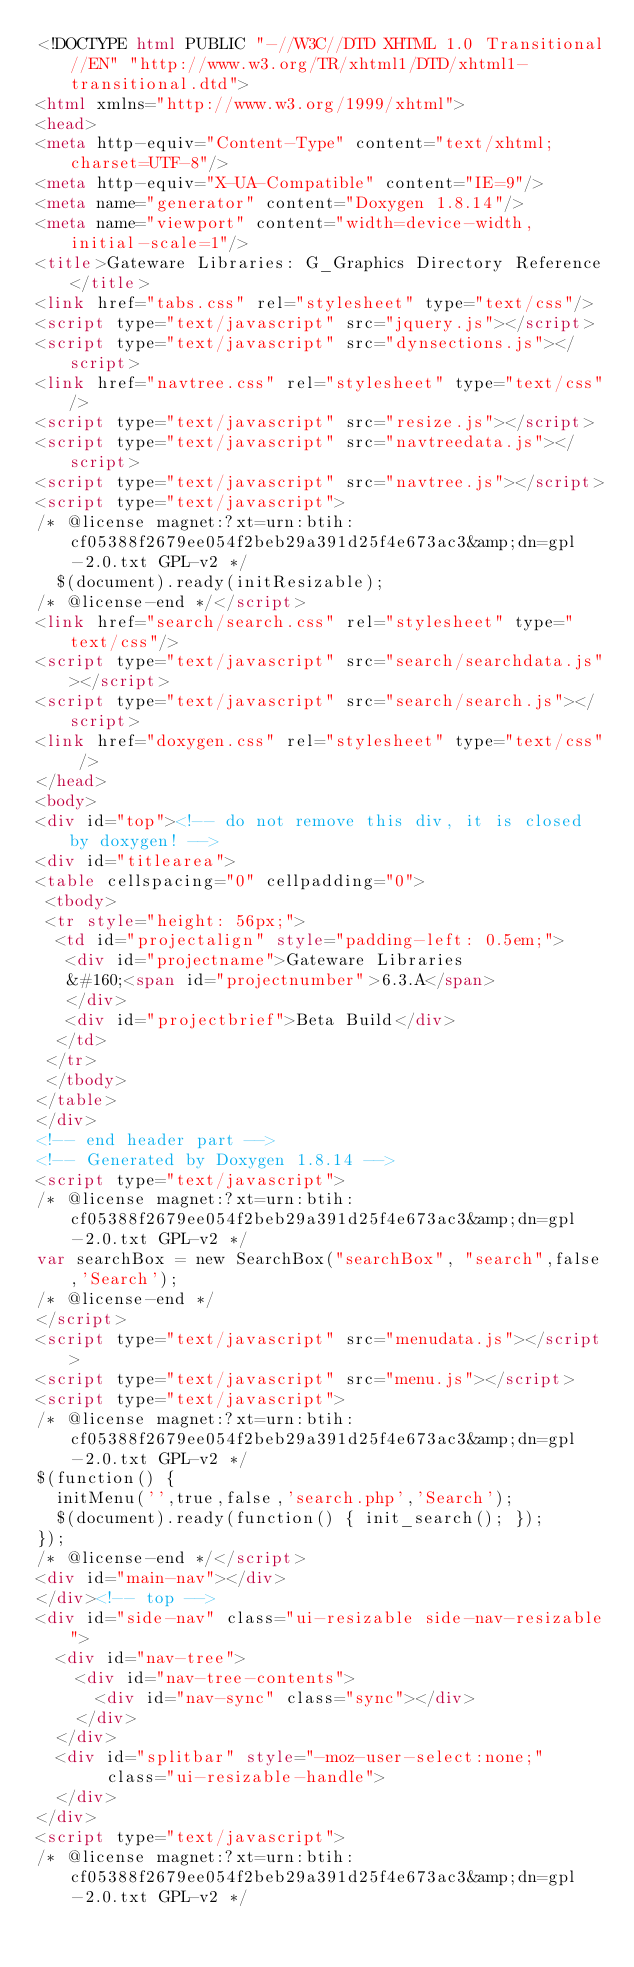Convert code to text. <code><loc_0><loc_0><loc_500><loc_500><_HTML_><!DOCTYPE html PUBLIC "-//W3C//DTD XHTML 1.0 Transitional//EN" "http://www.w3.org/TR/xhtml1/DTD/xhtml1-transitional.dtd">
<html xmlns="http://www.w3.org/1999/xhtml">
<head>
<meta http-equiv="Content-Type" content="text/xhtml;charset=UTF-8"/>
<meta http-equiv="X-UA-Compatible" content="IE=9"/>
<meta name="generator" content="Doxygen 1.8.14"/>
<meta name="viewport" content="width=device-width, initial-scale=1"/>
<title>Gateware Libraries: G_Graphics Directory Reference</title>
<link href="tabs.css" rel="stylesheet" type="text/css"/>
<script type="text/javascript" src="jquery.js"></script>
<script type="text/javascript" src="dynsections.js"></script>
<link href="navtree.css" rel="stylesheet" type="text/css"/>
<script type="text/javascript" src="resize.js"></script>
<script type="text/javascript" src="navtreedata.js"></script>
<script type="text/javascript" src="navtree.js"></script>
<script type="text/javascript">
/* @license magnet:?xt=urn:btih:cf05388f2679ee054f2beb29a391d25f4e673ac3&amp;dn=gpl-2.0.txt GPL-v2 */
  $(document).ready(initResizable);
/* @license-end */</script>
<link href="search/search.css" rel="stylesheet" type="text/css"/>
<script type="text/javascript" src="search/searchdata.js"></script>
<script type="text/javascript" src="search/search.js"></script>
<link href="doxygen.css" rel="stylesheet" type="text/css" />
</head>
<body>
<div id="top"><!-- do not remove this div, it is closed by doxygen! -->
<div id="titlearea">
<table cellspacing="0" cellpadding="0">
 <tbody>
 <tr style="height: 56px;">
  <td id="projectalign" style="padding-left: 0.5em;">
   <div id="projectname">Gateware Libraries
   &#160;<span id="projectnumber">6.3.A</span>
   </div>
   <div id="projectbrief">Beta Build</div>
  </td>
 </tr>
 </tbody>
</table>
</div>
<!-- end header part -->
<!-- Generated by Doxygen 1.8.14 -->
<script type="text/javascript">
/* @license magnet:?xt=urn:btih:cf05388f2679ee054f2beb29a391d25f4e673ac3&amp;dn=gpl-2.0.txt GPL-v2 */
var searchBox = new SearchBox("searchBox", "search",false,'Search');
/* @license-end */
</script>
<script type="text/javascript" src="menudata.js"></script>
<script type="text/javascript" src="menu.js"></script>
<script type="text/javascript">
/* @license magnet:?xt=urn:btih:cf05388f2679ee054f2beb29a391d25f4e673ac3&amp;dn=gpl-2.0.txt GPL-v2 */
$(function() {
  initMenu('',true,false,'search.php','Search');
  $(document).ready(function() { init_search(); });
});
/* @license-end */</script>
<div id="main-nav"></div>
</div><!-- top -->
<div id="side-nav" class="ui-resizable side-nav-resizable">
  <div id="nav-tree">
    <div id="nav-tree-contents">
      <div id="nav-sync" class="sync"></div>
    </div>
  </div>
  <div id="splitbar" style="-moz-user-select:none;" 
       class="ui-resizable-handle">
  </div>
</div>
<script type="text/javascript">
/* @license magnet:?xt=urn:btih:cf05388f2679ee054f2beb29a391d25f4e673ac3&amp;dn=gpl-2.0.txt GPL-v2 */</code> 